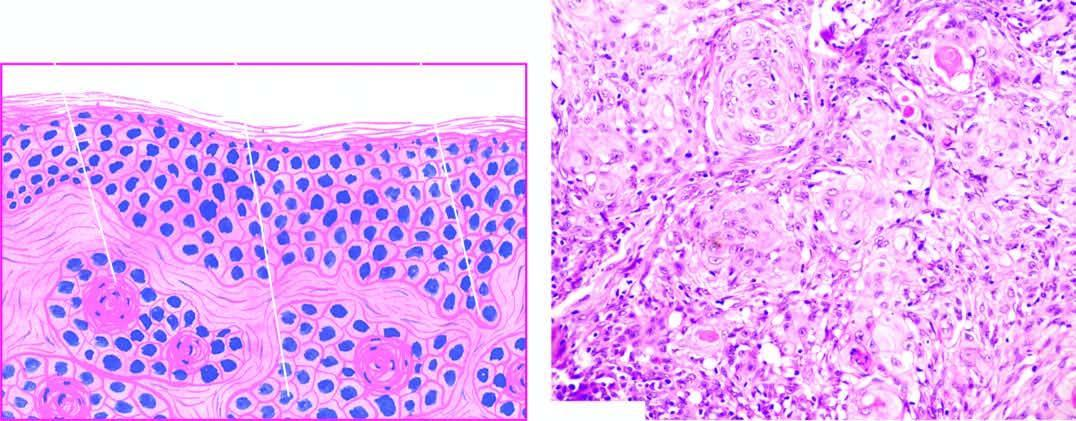what shows whorls of malignant squamous cells with central keratin pearls?
Answer the question using a single word or phrase. Microscopy 